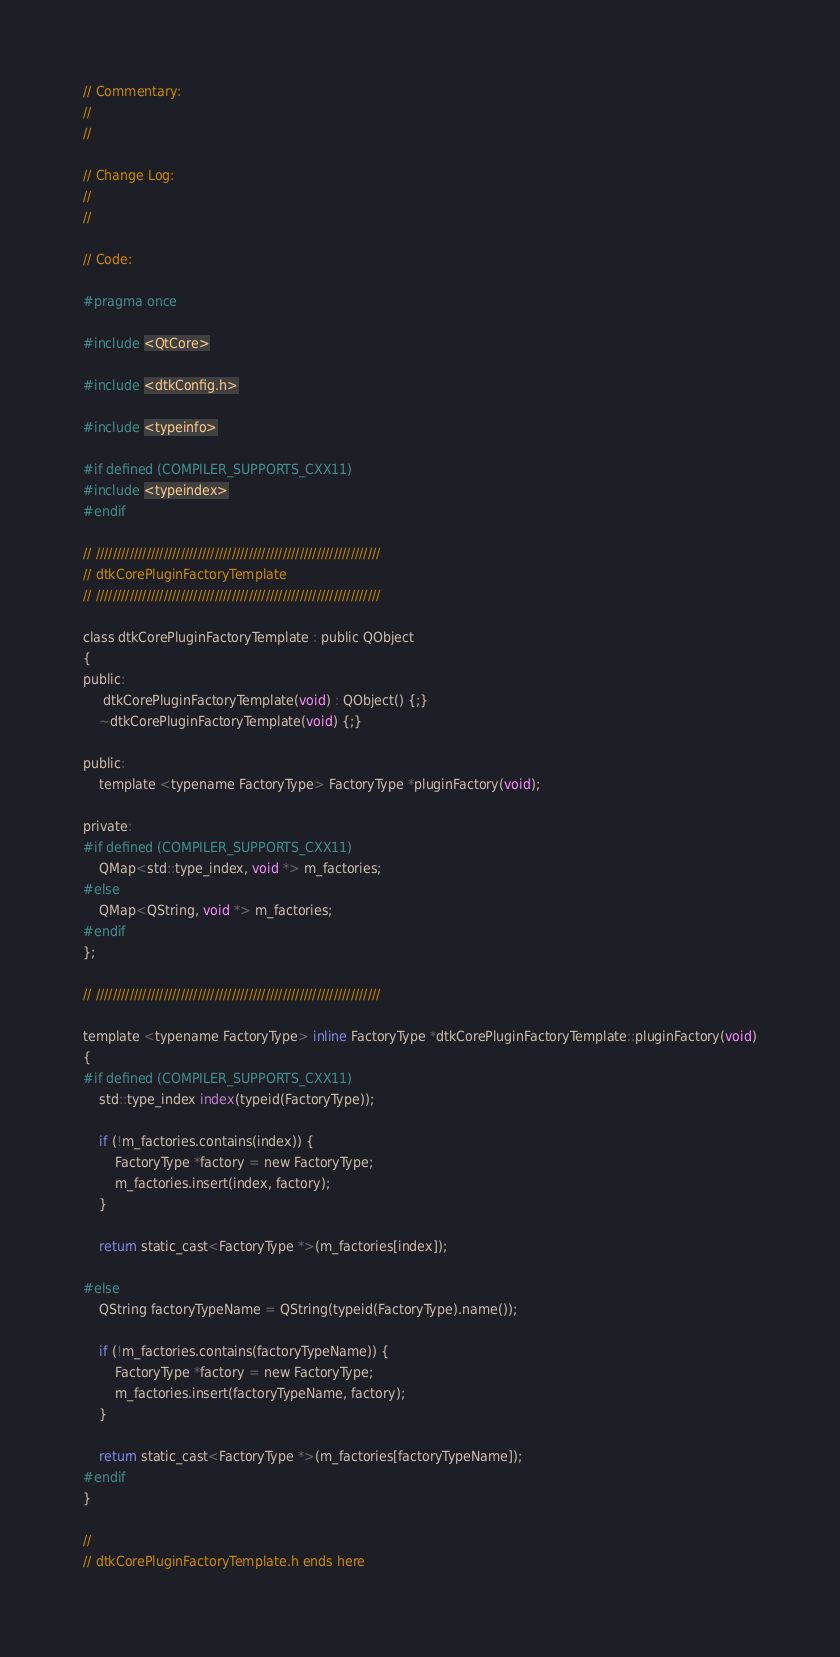<code> <loc_0><loc_0><loc_500><loc_500><_C_>
// Commentary: 
// 
// 

// Change Log:
// 
// 

// Code:

#pragma once

#include <QtCore>

#include <dtkConfig.h>

#include <typeinfo>

#if defined (COMPILER_SUPPORTS_CXX11)
#include <typeindex>
#endif

// ///////////////////////////////////////////////////////////////////
// dtkCorePluginFactoryTemplate
// ///////////////////////////////////////////////////////////////////

class dtkCorePluginFactoryTemplate : public QObject
{
public:
     dtkCorePluginFactoryTemplate(void) : QObject() {;}
    ~dtkCorePluginFactoryTemplate(void) {;}

public:
    template <typename FactoryType> FactoryType *pluginFactory(void);

private:
#if defined (COMPILER_SUPPORTS_CXX11)
    QMap<std::type_index, void *> m_factories;
#else
    QMap<QString, void *> m_factories;
#endif
};

// ///////////////////////////////////////////////////////////////////

template <typename FactoryType> inline FactoryType *dtkCorePluginFactoryTemplate::pluginFactory(void)
{
#if defined (COMPILER_SUPPORTS_CXX11)
    std::type_index index(typeid(FactoryType));

    if (!m_factories.contains(index)) {
        FactoryType *factory = new FactoryType;
        m_factories.insert(index, factory);
    }

    return static_cast<FactoryType *>(m_factories[index]);

#else
    QString factoryTypeName = QString(typeid(FactoryType).name());

    if (!m_factories.contains(factoryTypeName)) {
        FactoryType *factory = new FactoryType;
        m_factories.insert(factoryTypeName, factory);
    }
    
    return static_cast<FactoryType *>(m_factories[factoryTypeName]);
#endif
}

// 
// dtkCorePluginFactoryTemplate.h ends here
</code> 